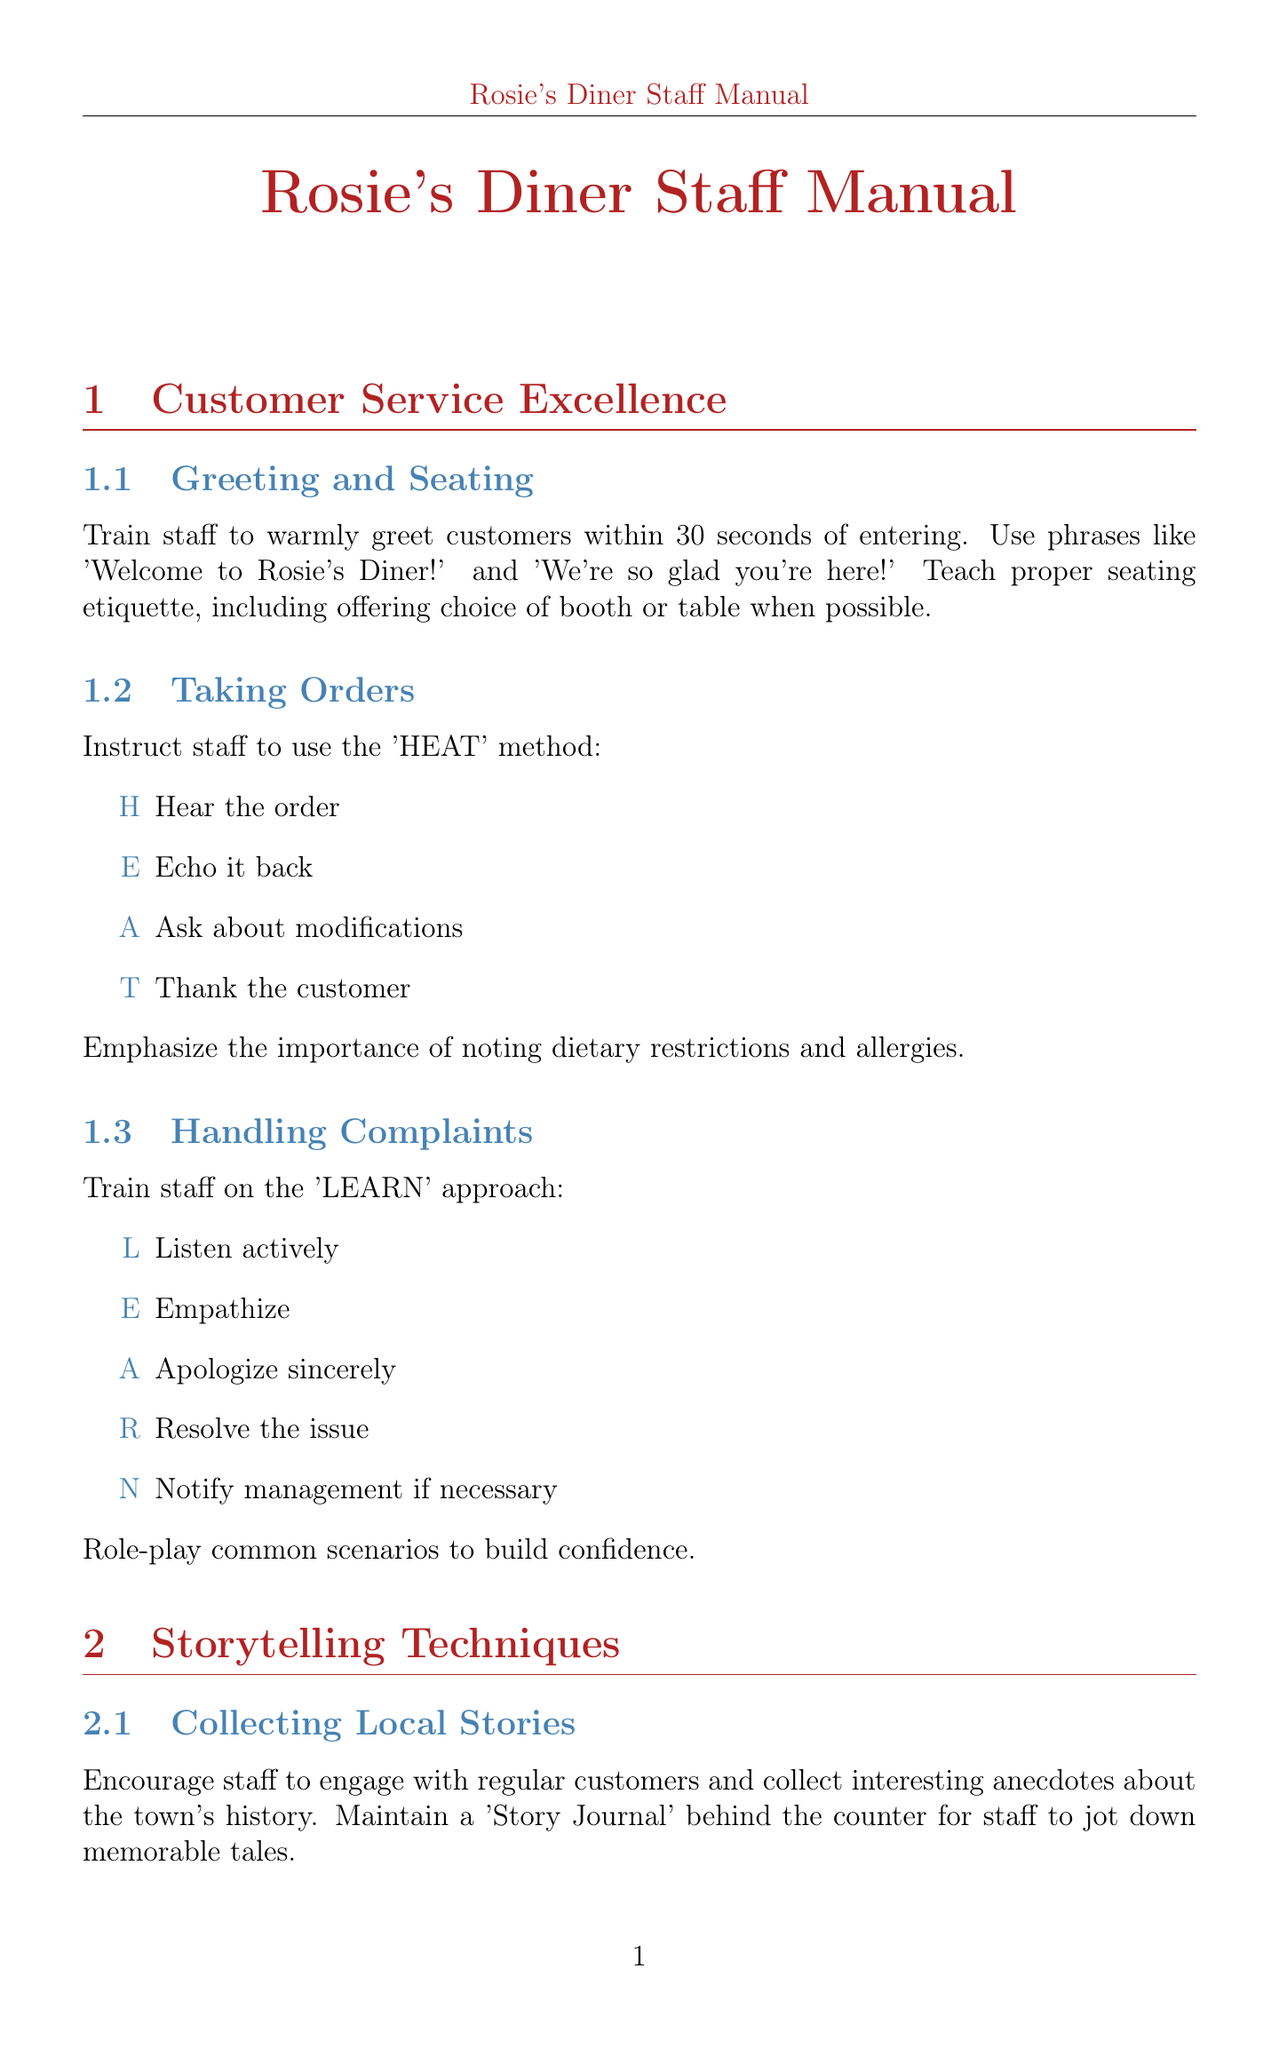what is the first method staff should use when taking orders? The first method is the 'HEAT' method, consisting of Hear, Echo, Ask, and Thank.
Answer: 'HEAT' what does the 'LEARN' approach stand for? The 'LEARN' approach stands for Listen, Empathize, Apologize, Resolve, and Notify.
Answer: 'LEARN' how often should the community events board be updated? The community events board should be updated weekly with local happenings.
Answer: weekly who manages the local events board? A staff member is assigned to manage the community events board.
Answer: staff member what method is taught for crafting engaging narratives? The method taught for crafting engaging narratives is the 'STAR' method.
Answer: 'STAR' how many sections are there in the manual? There are five sections within the manual.
Answer: five what type of atmosphere should staff maintain? Staff should maintain a classic diner feel.
Answer: classic diner feel what is the frequency of the 'Pancakes for a Cause' event? The 'Pancakes for a Cause' event takes place monthly.
Answer: monthly how should servers present the pancakes? Servers should present pancakes by stacking, buttering, and garnishing the dishes.
Answer: stacking, buttering, and garnishing 